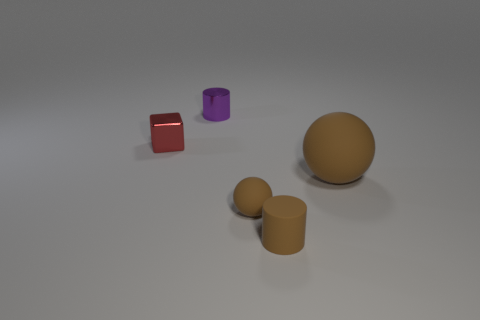What shape is the large thing that is the same color as the tiny sphere?
Ensure brevity in your answer.  Sphere. What material is the cylinder that is the same color as the large matte thing?
Offer a terse response. Rubber. What is the material of the small brown cylinder?
Offer a terse response. Rubber. How many other things are there of the same color as the tiny sphere?
Give a very brief answer. 2. Is the color of the small ball the same as the rubber cylinder?
Your answer should be very brief. Yes. How many tiny red shiny cylinders are there?
Your response must be concise. 0. What material is the small cylinder that is in front of the metal thing that is to the left of the purple cylinder made of?
Offer a terse response. Rubber. What is the material of the brown cylinder that is the same size as the red thing?
Provide a succinct answer. Rubber. Do the thing that is left of the purple object and the big thing have the same size?
Ensure brevity in your answer.  No. Do the matte thing in front of the tiny sphere and the purple shiny object have the same shape?
Provide a short and direct response. Yes. 